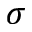<formula> <loc_0><loc_0><loc_500><loc_500>\sigma</formula> 